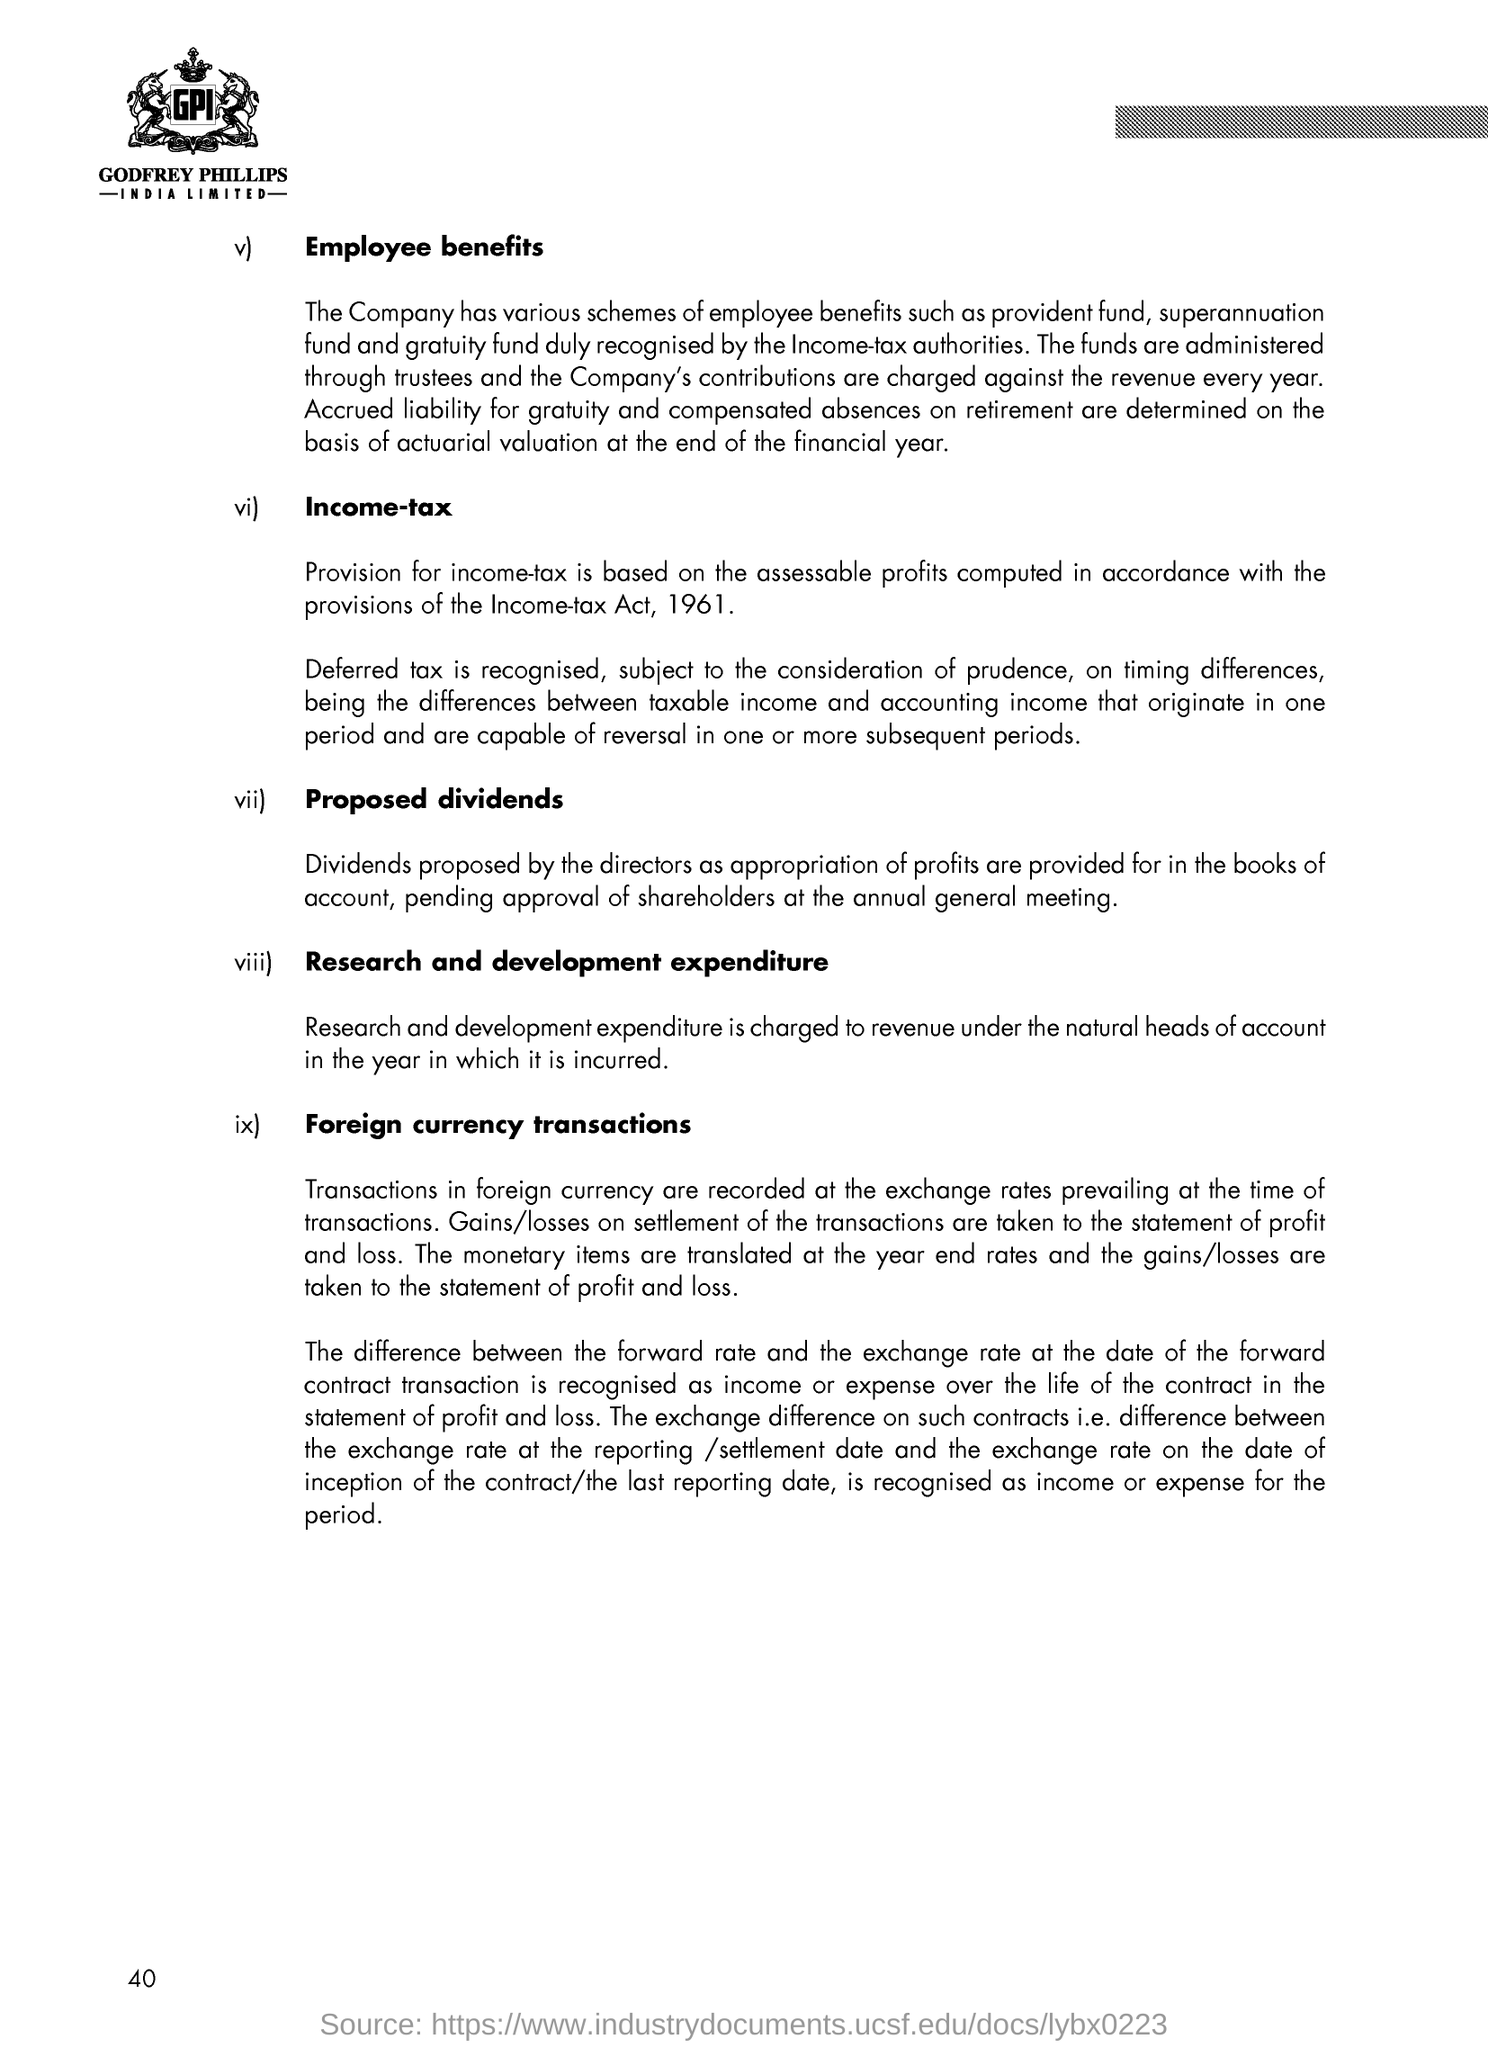Give some essential details in this illustration. The natural heads of account in the year included research and development expenditure, which was charged and recorded as a revenue item. What was deferred tax considered subject to prudence? The income-tax authorities are the authorities that duly recognize the provident fund, superannuation fund, and gratuity fund. The directors proposed the dividends. The heading given to the first paragraph is "Employee benefits. 